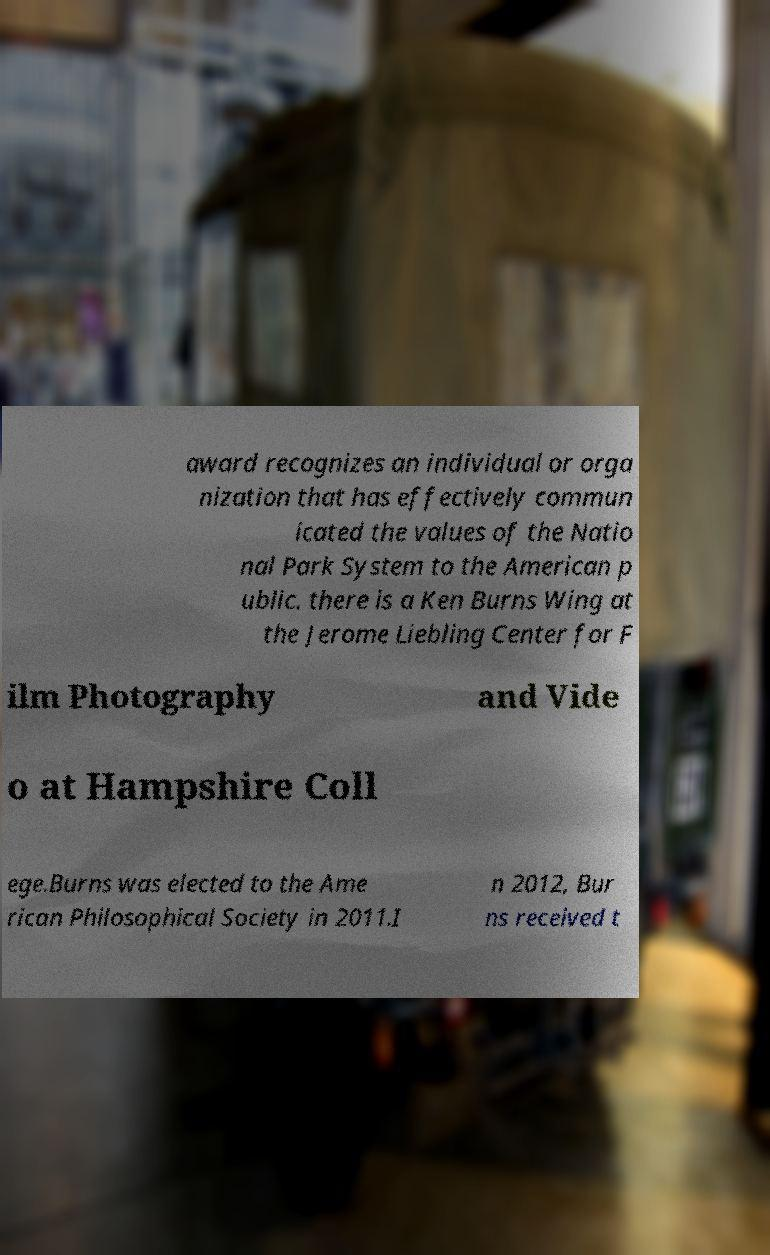Please identify and transcribe the text found in this image. award recognizes an individual or orga nization that has effectively commun icated the values of the Natio nal Park System to the American p ublic. there is a Ken Burns Wing at the Jerome Liebling Center for F ilm Photography and Vide o at Hampshire Coll ege.Burns was elected to the Ame rican Philosophical Society in 2011.I n 2012, Bur ns received t 